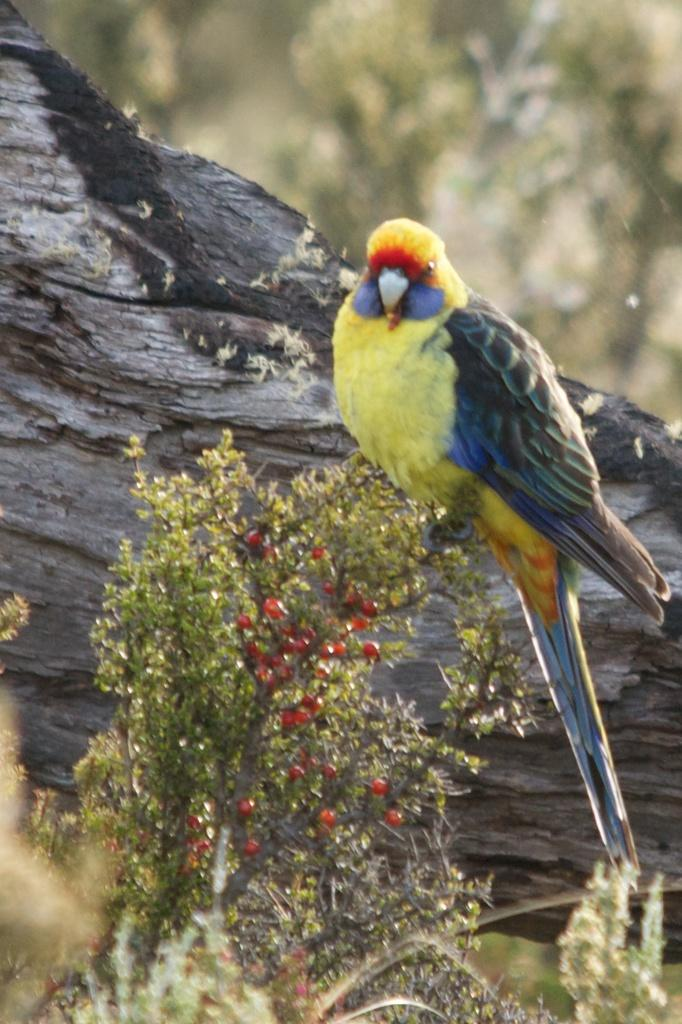What type of bird is in the picture? There is a Loriini in the picture. Where is the Loriini located in the image? The Loriini is present on a plant. What is the position of the plant in the image? The plant is on the ground. What can be seen in the background of the image? There is a log visible in the background of the image. What type of holiday is the Loriini celebrating in the image? There is no indication of a holiday in the image; it simply features a Loriini on a plant. Is the Loriini sleeping in the image? There is no indication that the Loriini is sleeping in the image; it is perched on a plant. 